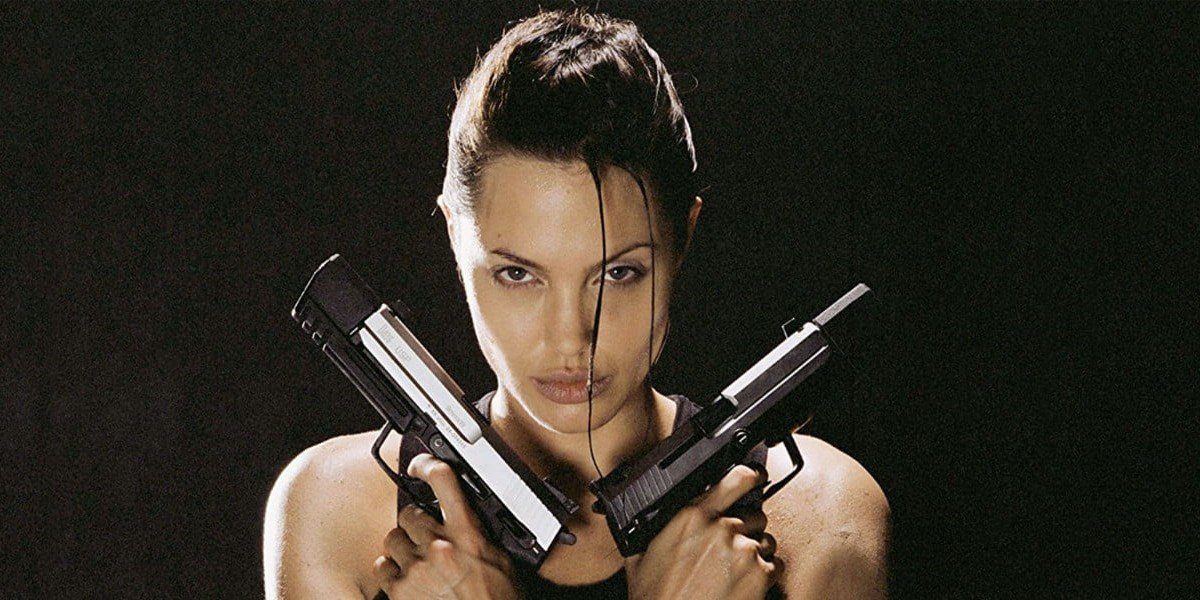What kind of backstory does this character likely have? The character likely has a backstory filled with intense training, difficult choices, and significant personal losses that have shaped her resilient and formidable demeanor. She might have been thrust into a life of adventure and combat from a young age, fueled by a quest to find something or someone. Her experiences have made her tough, resourceful, and highly skilled in survival and combat. Despite the hardships, her journey has also taught her the importance of justice, protection, and courage. Can you imagine a moment of introspection for this character? In a rare moment of introspection, the character sits by a quiet campfire under a starlit sky. The guns that usually sit in her hands are safely holstered as she stares into the dancing flames. Memories of her past, both painful and triumphant, flicker in her mind. She reflects on the paths she has chosen, the lives she’s impacted, and the battles she’s fought. In this solitary moment, the tough exterior she presents to the world softens, revealing a deeply thoughtful and introspective individual who questions the true cost of her relentless pursuit of justice and adventure. This vulnerability, however fleeting, adds a layer of depth to her otherwise unyielding character. 